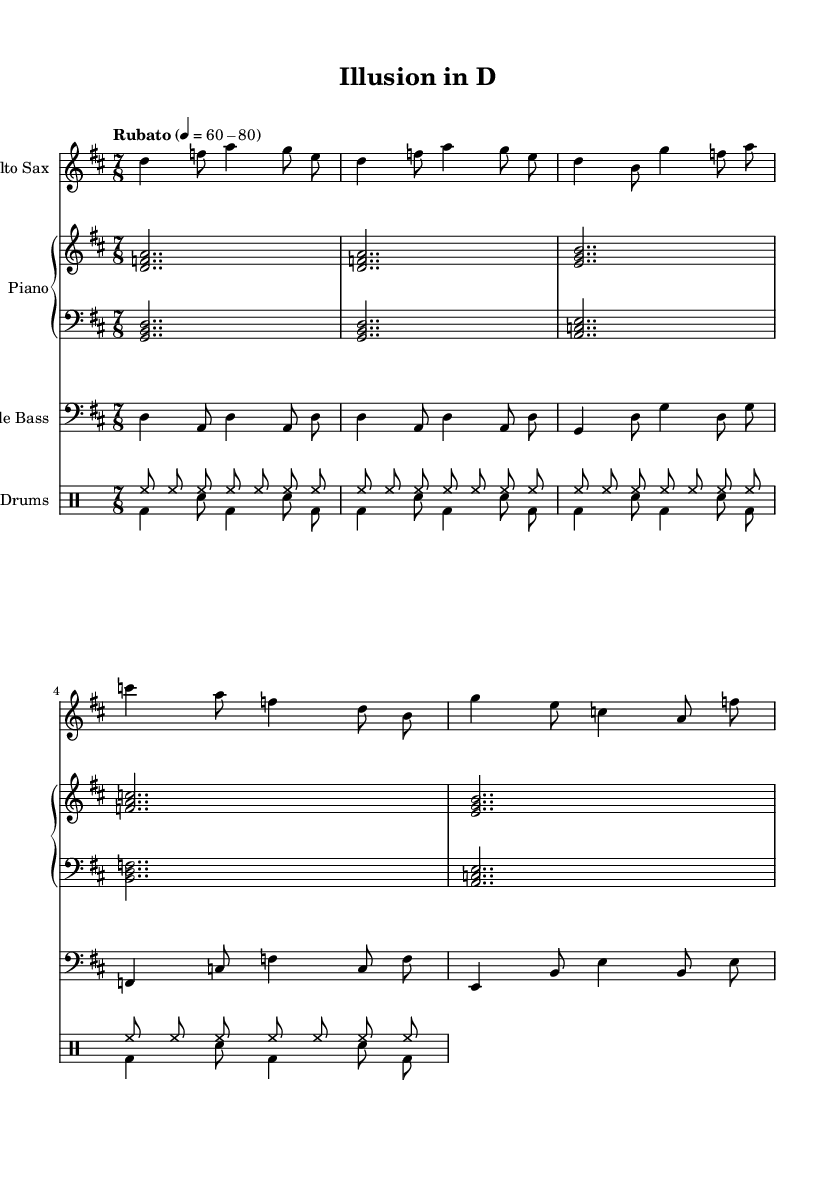What is the key signature of this music? The key signature is indicated at the beginning of the music, showing that there are two sharps, which corresponds to D major.
Answer: D major What is the time signature of this piece? The time signature is displayed at the beginning of the music notation, indicating that there are seven beats in each measure.
Answer: 7/8 What is the tempo marking for this composition? The tempo marking is found at the beginning, stating "Rubato," which implies a flexible tempo with a range of beats per minute between 60 and 80.
Answer: Rubato 4 = 60-80 Which instrument plays the bass line? The bass line is indicated by the clef and instrument name at the start of the staff, which shows that the double bass is responsible for playing the bass line.
Answer: Double Bass How many themes are present in this composition? By examining the sections in the music, there are two distinct themes labeled as Theme A and Theme B.
Answer: Two What creates the jazz composition's sense of depth and perspective? The use of varied textures and contrasting dynamics throughout the piece contributes to a sense of depth and perspective typical of avant-garde jazz.
Answer: Varied textures 